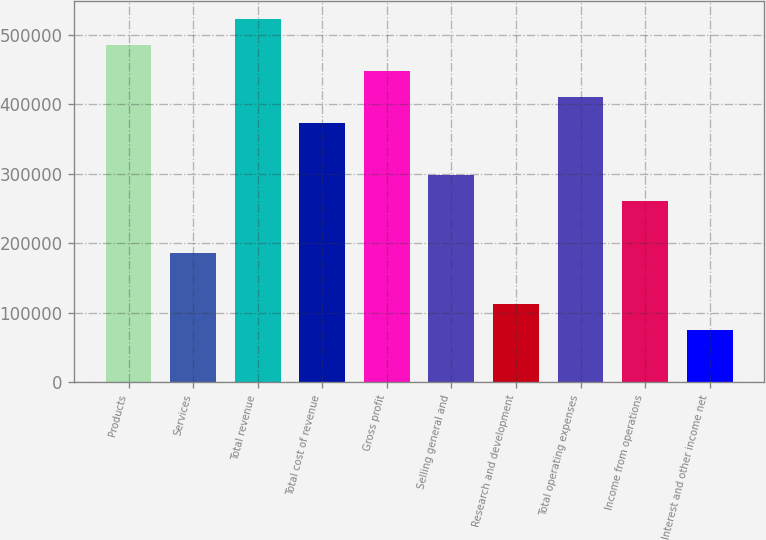<chart> <loc_0><loc_0><loc_500><loc_500><bar_chart><fcel>Products<fcel>Services<fcel>Total revenue<fcel>Total cost of revenue<fcel>Gross profit<fcel>Selling general and<fcel>Research and development<fcel>Total operating expenses<fcel>Income from operations<fcel>Interest and other income net<nl><fcel>484486<fcel>186342<fcel>521754<fcel>372682<fcel>447218<fcel>298146<fcel>111806<fcel>409950<fcel>260878<fcel>74537.9<nl></chart> 